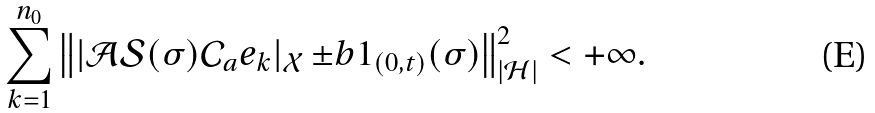Convert formula to latex. <formula><loc_0><loc_0><loc_500><loc_500>\sum _ { k = 1 } ^ { n _ { 0 } } \left \| | { \mathcal { A } } { \mathcal { S } } ( \sigma ) { \mathcal { C } } _ { a } e _ { k } | _ { \mathcal { X } } \, { \pm b 1 } _ { ( 0 , t ) } ( \sigma ) \right \| ^ { 2 } _ { | { \mathcal { H } } | } < + \infty .</formula> 